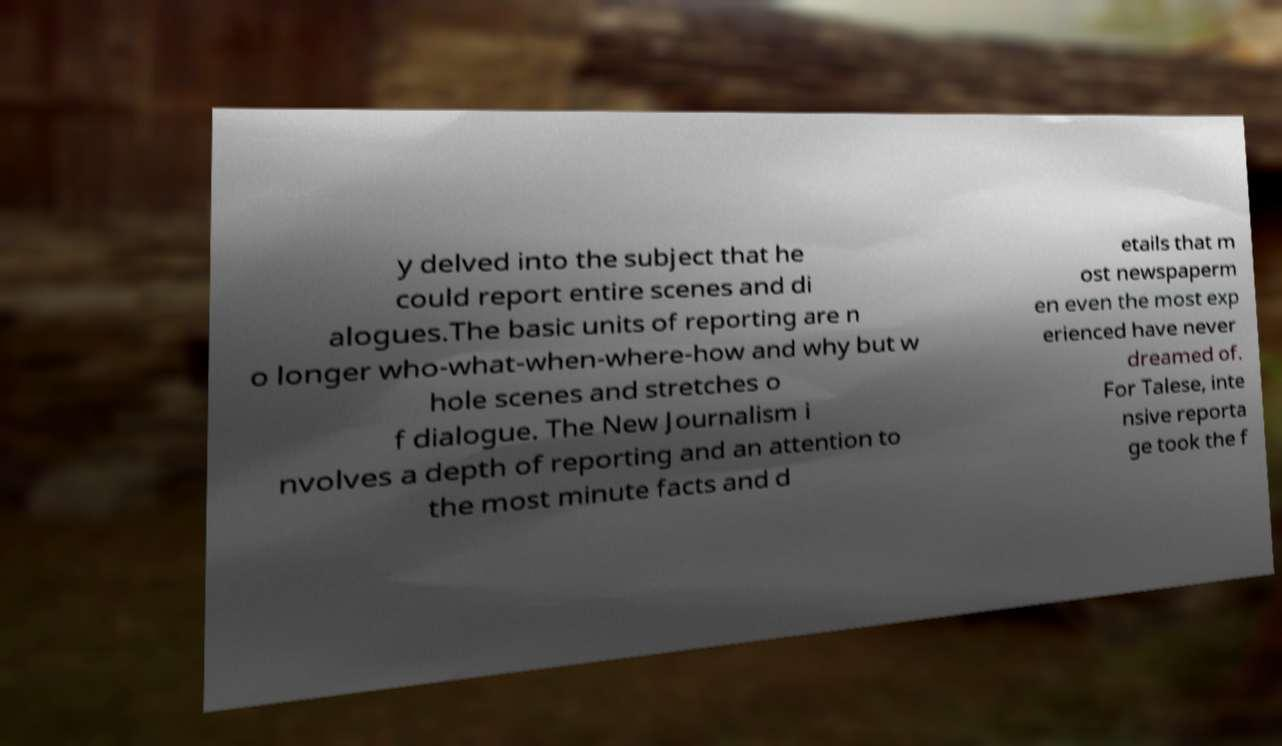What messages or text are displayed in this image? I need them in a readable, typed format. y delved into the subject that he could report entire scenes and di alogues.The basic units of reporting are n o longer who-what-when-where-how and why but w hole scenes and stretches o f dialogue. The New Journalism i nvolves a depth of reporting and an attention to the most minute facts and d etails that m ost newspaperm en even the most exp erienced have never dreamed of. For Talese, inte nsive reporta ge took the f 